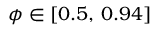<formula> <loc_0><loc_0><loc_500><loc_500>\phi \in [ 0 . 5 , \, 0 . 9 4 ]</formula> 